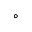<formula> <loc_0><loc_0><loc_500><loc_500>^ { \circ }</formula> 